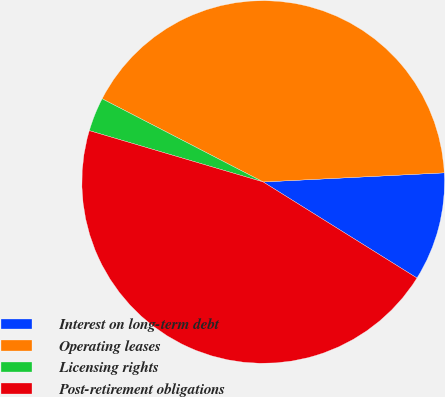<chart> <loc_0><loc_0><loc_500><loc_500><pie_chart><fcel>Interest on long-term debt<fcel>Operating leases<fcel>Licensing rights<fcel>Post-retirement obligations<nl><fcel>9.69%<fcel>41.61%<fcel>3.02%<fcel>45.68%<nl></chart> 